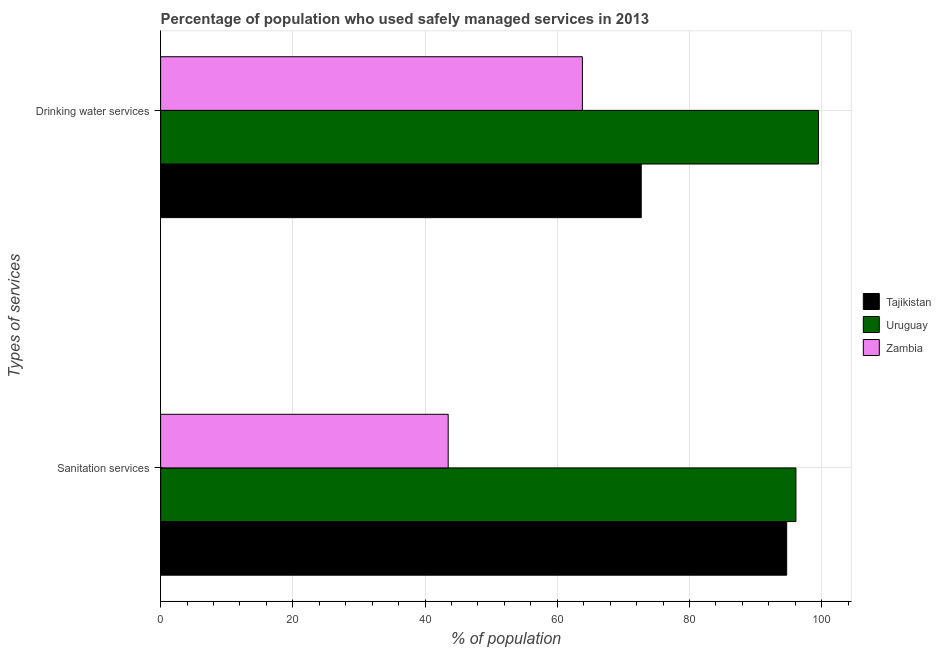How many groups of bars are there?
Provide a short and direct response. 2. Are the number of bars on each tick of the Y-axis equal?
Your response must be concise. Yes. How many bars are there on the 2nd tick from the top?
Your response must be concise. 3. What is the label of the 1st group of bars from the top?
Provide a short and direct response. Drinking water services. What is the percentage of population who used drinking water services in Tajikistan?
Your response must be concise. 72.7. Across all countries, what is the maximum percentage of population who used drinking water services?
Provide a succinct answer. 99.5. Across all countries, what is the minimum percentage of population who used sanitation services?
Give a very brief answer. 43.5. In which country was the percentage of population who used sanitation services maximum?
Make the answer very short. Uruguay. In which country was the percentage of population who used sanitation services minimum?
Offer a very short reply. Zambia. What is the total percentage of population who used sanitation services in the graph?
Make the answer very short. 234.3. What is the difference between the percentage of population who used sanitation services in Zambia and that in Tajikistan?
Offer a terse response. -51.2. What is the difference between the percentage of population who used sanitation services in Tajikistan and the percentage of population who used drinking water services in Zambia?
Ensure brevity in your answer.  30.9. What is the average percentage of population who used sanitation services per country?
Keep it short and to the point. 78.1. What is the difference between the percentage of population who used drinking water services and percentage of population who used sanitation services in Zambia?
Provide a succinct answer. 20.3. What is the ratio of the percentage of population who used drinking water services in Tajikistan to that in Zambia?
Your answer should be very brief. 1.14. In how many countries, is the percentage of population who used drinking water services greater than the average percentage of population who used drinking water services taken over all countries?
Your answer should be compact. 1. What does the 3rd bar from the top in Sanitation services represents?
Ensure brevity in your answer.  Tajikistan. What does the 2nd bar from the bottom in Sanitation services represents?
Provide a short and direct response. Uruguay. What is the difference between two consecutive major ticks on the X-axis?
Provide a succinct answer. 20. Does the graph contain any zero values?
Offer a terse response. No. Does the graph contain grids?
Your answer should be compact. Yes. How many legend labels are there?
Your answer should be compact. 3. How are the legend labels stacked?
Your answer should be compact. Vertical. What is the title of the graph?
Provide a short and direct response. Percentage of population who used safely managed services in 2013. What is the label or title of the X-axis?
Offer a terse response. % of population. What is the label or title of the Y-axis?
Offer a terse response. Types of services. What is the % of population of Tajikistan in Sanitation services?
Your answer should be compact. 94.7. What is the % of population of Uruguay in Sanitation services?
Offer a terse response. 96.1. What is the % of population of Zambia in Sanitation services?
Your answer should be very brief. 43.5. What is the % of population in Tajikistan in Drinking water services?
Keep it short and to the point. 72.7. What is the % of population of Uruguay in Drinking water services?
Make the answer very short. 99.5. What is the % of population of Zambia in Drinking water services?
Offer a very short reply. 63.8. Across all Types of services, what is the maximum % of population in Tajikistan?
Keep it short and to the point. 94.7. Across all Types of services, what is the maximum % of population of Uruguay?
Ensure brevity in your answer.  99.5. Across all Types of services, what is the maximum % of population of Zambia?
Ensure brevity in your answer.  63.8. Across all Types of services, what is the minimum % of population in Tajikistan?
Your answer should be very brief. 72.7. Across all Types of services, what is the minimum % of population in Uruguay?
Your answer should be compact. 96.1. Across all Types of services, what is the minimum % of population of Zambia?
Your response must be concise. 43.5. What is the total % of population in Tajikistan in the graph?
Offer a terse response. 167.4. What is the total % of population of Uruguay in the graph?
Your answer should be very brief. 195.6. What is the total % of population in Zambia in the graph?
Provide a succinct answer. 107.3. What is the difference between the % of population in Tajikistan in Sanitation services and that in Drinking water services?
Make the answer very short. 22. What is the difference between the % of population in Uruguay in Sanitation services and that in Drinking water services?
Provide a succinct answer. -3.4. What is the difference between the % of population in Zambia in Sanitation services and that in Drinking water services?
Your answer should be very brief. -20.3. What is the difference between the % of population of Tajikistan in Sanitation services and the % of population of Zambia in Drinking water services?
Make the answer very short. 30.9. What is the difference between the % of population in Uruguay in Sanitation services and the % of population in Zambia in Drinking water services?
Make the answer very short. 32.3. What is the average % of population of Tajikistan per Types of services?
Provide a short and direct response. 83.7. What is the average % of population in Uruguay per Types of services?
Provide a succinct answer. 97.8. What is the average % of population of Zambia per Types of services?
Keep it short and to the point. 53.65. What is the difference between the % of population in Tajikistan and % of population in Zambia in Sanitation services?
Your answer should be very brief. 51.2. What is the difference between the % of population in Uruguay and % of population in Zambia in Sanitation services?
Offer a terse response. 52.6. What is the difference between the % of population of Tajikistan and % of population of Uruguay in Drinking water services?
Your answer should be very brief. -26.8. What is the difference between the % of population in Tajikistan and % of population in Zambia in Drinking water services?
Ensure brevity in your answer.  8.9. What is the difference between the % of population of Uruguay and % of population of Zambia in Drinking water services?
Keep it short and to the point. 35.7. What is the ratio of the % of population of Tajikistan in Sanitation services to that in Drinking water services?
Make the answer very short. 1.3. What is the ratio of the % of population in Uruguay in Sanitation services to that in Drinking water services?
Your answer should be compact. 0.97. What is the ratio of the % of population of Zambia in Sanitation services to that in Drinking water services?
Keep it short and to the point. 0.68. What is the difference between the highest and the second highest % of population in Zambia?
Give a very brief answer. 20.3. What is the difference between the highest and the lowest % of population of Tajikistan?
Provide a succinct answer. 22. What is the difference between the highest and the lowest % of population in Zambia?
Your response must be concise. 20.3. 